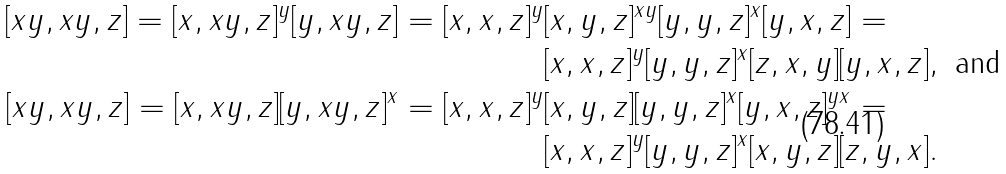<formula> <loc_0><loc_0><loc_500><loc_500>[ x y , x y , z ] = [ x , x y , z ] ^ { y } [ y , x y , z ] = [ x , x , z ] ^ { y } & [ x , y , z ] ^ { x y } [ y , y , z ] ^ { x } [ y , x , z ] = \\ & [ x , x , z ] ^ { y } [ y , y , z ] ^ { x } [ z , x , y ] [ y , x , z ] , \text { and} \\ [ x y , x y , z ] = [ x , x y , z ] [ y , x y , z ] ^ { x } = [ x , x , z ] ^ { y } & [ x , y , z ] [ y , y , z ] ^ { x } [ y , x , z ] ^ { y x } = \\ & [ x , x , z ] ^ { y } [ y , y , z ] ^ { x } [ x , y , z ] [ z , y , x ] .</formula> 